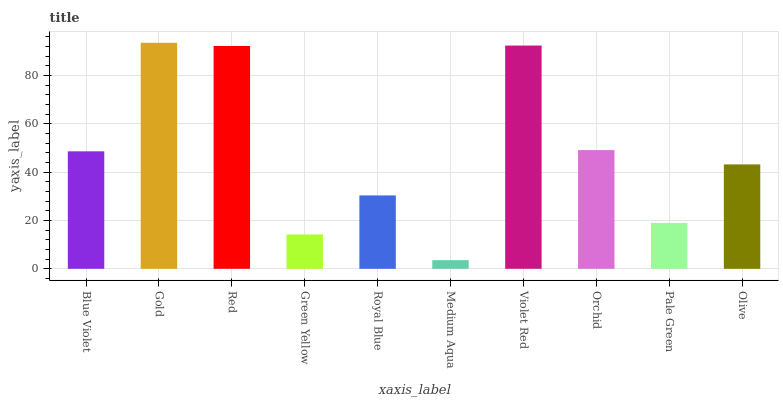Is Medium Aqua the minimum?
Answer yes or no. Yes. Is Gold the maximum?
Answer yes or no. Yes. Is Red the minimum?
Answer yes or no. No. Is Red the maximum?
Answer yes or no. No. Is Gold greater than Red?
Answer yes or no. Yes. Is Red less than Gold?
Answer yes or no. Yes. Is Red greater than Gold?
Answer yes or no. No. Is Gold less than Red?
Answer yes or no. No. Is Blue Violet the high median?
Answer yes or no. Yes. Is Olive the low median?
Answer yes or no. Yes. Is Violet Red the high median?
Answer yes or no. No. Is Blue Violet the low median?
Answer yes or no. No. 